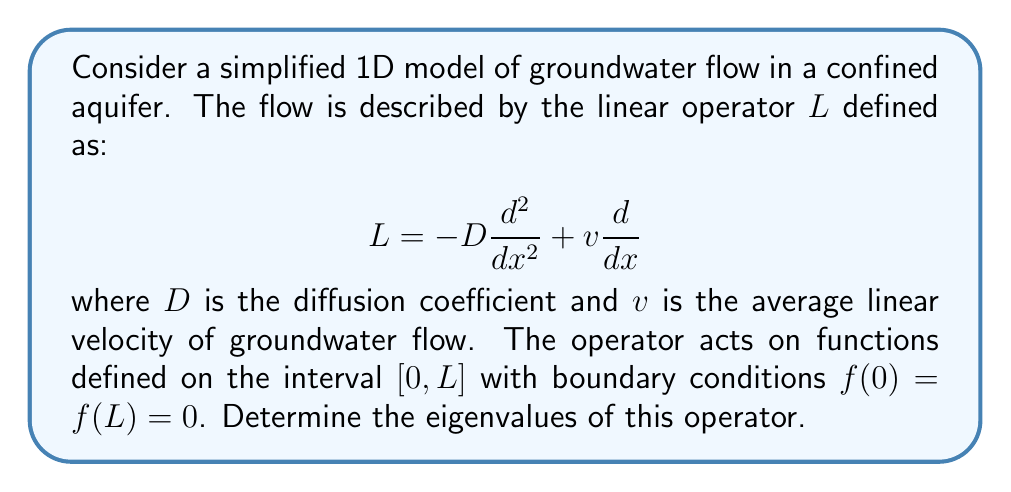Can you solve this math problem? To find the eigenvalues of the linear operator $L$, we need to solve the eigenvalue problem:

$$L\phi = \lambda\phi$$

where $\phi$ is an eigenfunction and $\lambda$ is the corresponding eigenvalue.

Step 1: Write out the full eigenvalue equation:
$$-D\frac{d^2\phi}{dx^2} + v\frac{d\phi}{dx} = \lambda\phi$$

Step 2: Assume a solution of the form $\phi(x) = e^{rx}$, where $r$ is a complex number.

Step 3: Substitute this into the eigenvalue equation:
$$-Dr^2e^{rx} + vre^{rx} = \lambda e^{rx}$$

Step 4: Simplify to get the characteristic equation:
$$-Dr^2 + vr = \lambda$$

Step 5: Solve for $r$:
$$r = \frac{v \pm \sqrt{v^2 + 4D\lambda}}{2D}$$

Step 6: Apply the boundary conditions. For $\phi(0) = \phi(L) = 0$, we must have:
$$\phi(x) = A\sin(\frac{n\pi x}{L}), \quad n = 1, 2, 3, ...$$

Step 7: Compare this with our assumed solution $e^{rx}$. We can conclude that:
$$r = \frac{v}{2D} \pm i\frac{\sqrt{4D\lambda - v^2}}{2D} = i\frac{n\pi}{L}$$

Step 8: Equate the imaginary parts:
$$\frac{\sqrt{4D\lambda - v^2}}{2D} = \frac{n\pi}{L}$$

Step 9: Solve for $\lambda$:
$$\lambda = \frac{D n^2\pi^2}{L^2} + \frac{v^2}{4D}, \quad n = 1, 2, 3, ...$$

This gives us the eigenvalues of the operator $L$.
Answer: The eigenvalues of the linear operator $L$ are:

$$\lambda_n = \frac{D n^2\pi^2}{L^2} + \frac{v^2}{4D}, \quad n = 1, 2, 3, ...$$

where $D$ is the diffusion coefficient, $v$ is the average linear velocity of groundwater flow, and $L$ is the length of the interval. 